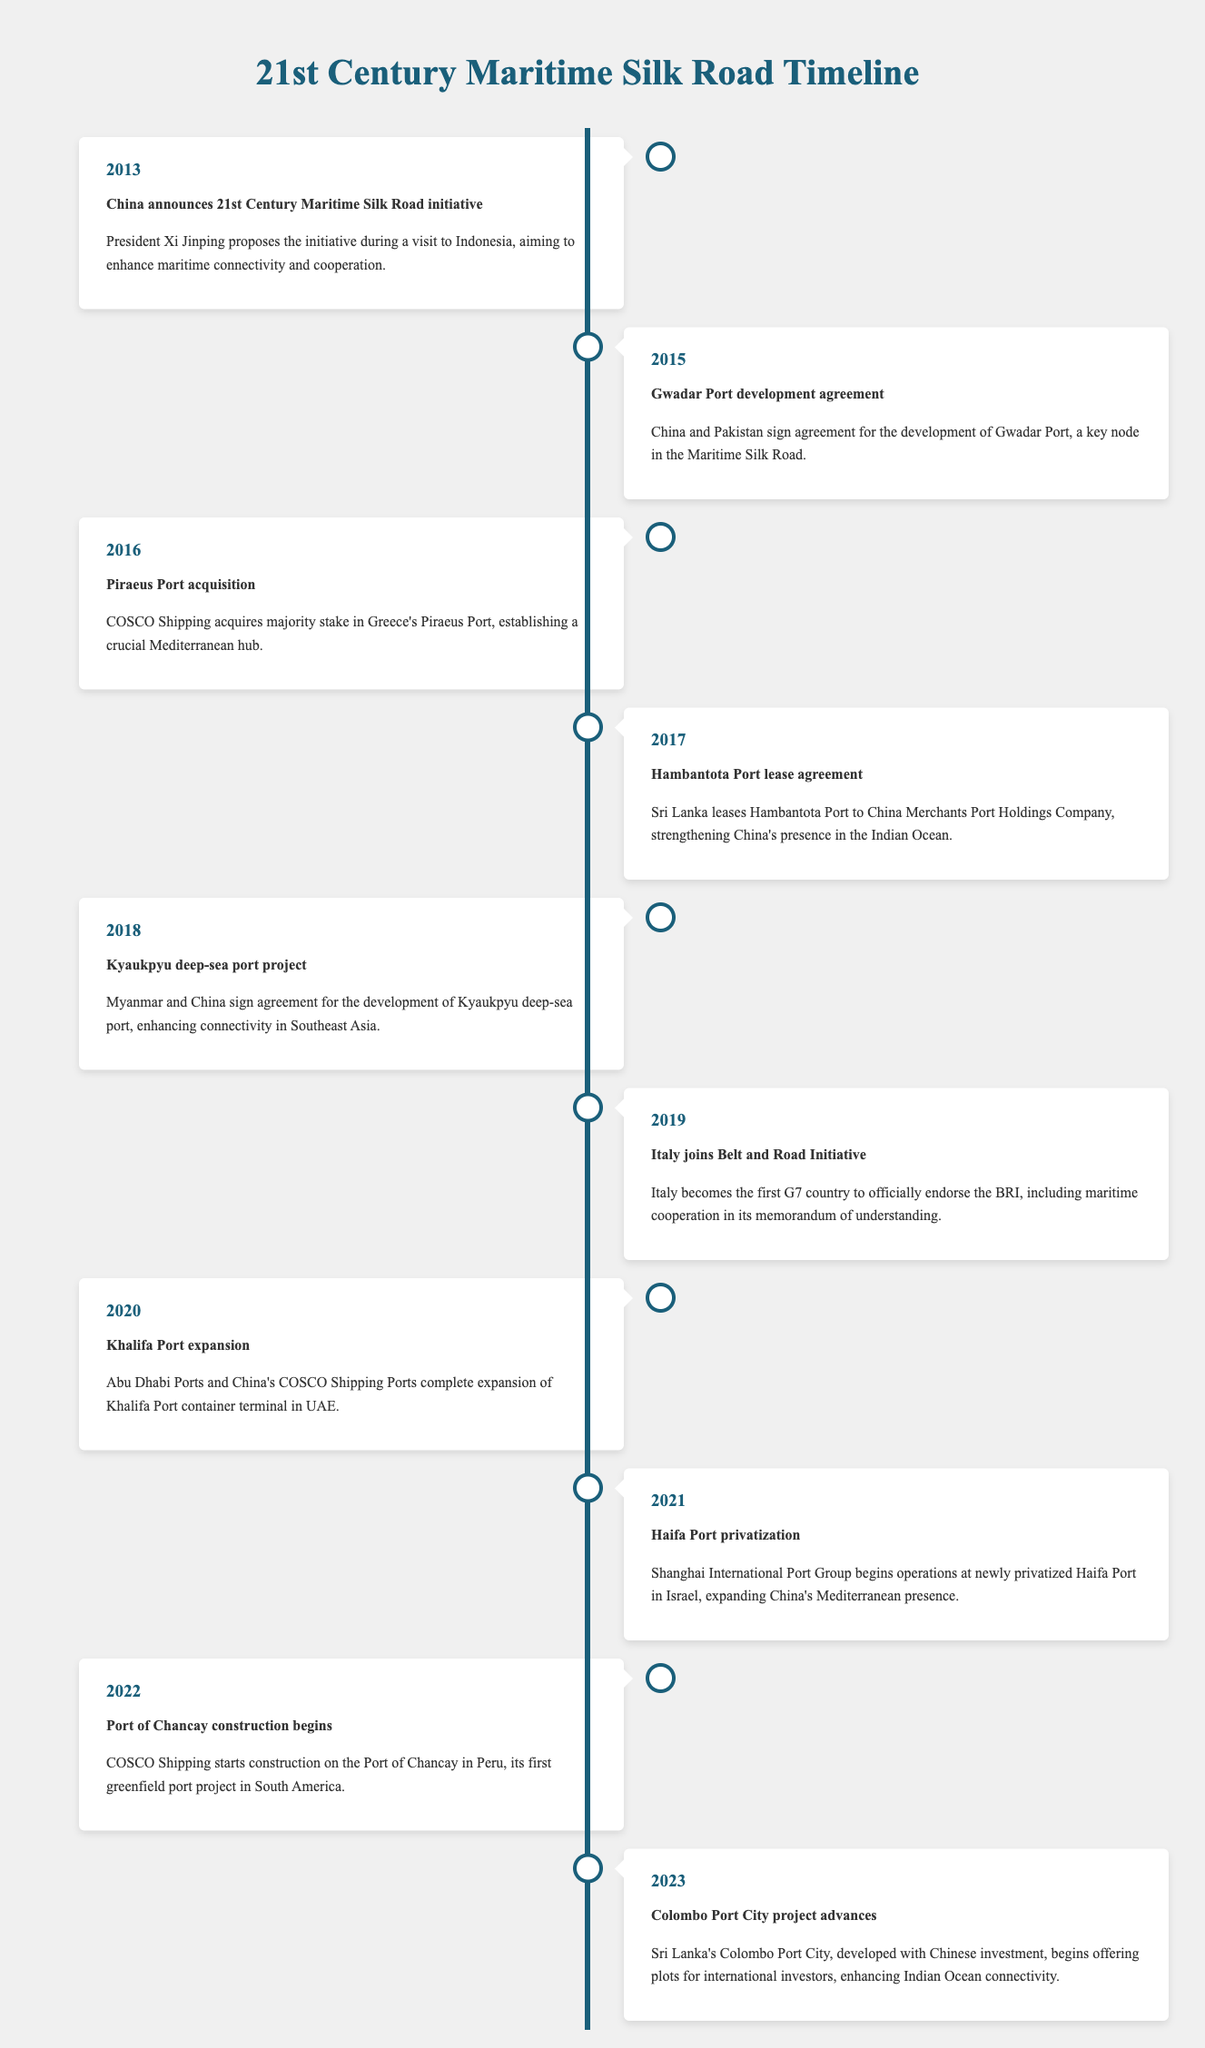What year was the 21st Century Maritime Silk Road initiative announced? The table shows that the initiative was announced in the year 2013, which is the first event listed.
Answer: 2013 Which country was involved in the Gwadar Port development agreement? According to the table, the Gwadar Port development agreement was signed between China and Pakistan in 2015.
Answer: Pakistan How many years passed between the announcement of the Maritime Silk Road and the acquisition of Piraeus Port? The initiative was announced in 2013, and the acquisition of Piraeus Port occurred in 2016. The difference is 2016 - 2013 = 3 years.
Answer: 3 years Was Italy the first G7 country to join the Belt and Road Initiative? Yes, the table specifically states that Italy became the first G7 country to endorse the initiative in 2019.
Answer: Yes What significant event regarding ports happened in 2021? In 2021, the table indicates that the Haifa Port was privatized and the Shanghai International Port Group began operations there, marking a significant event in that year.
Answer: Haifa Port privatization What is the trend of port development agreements from 2015 to 2023? Starting from 2015, several key port agreements occurred including Gwadar Port, Hambantota, and various expansions and projects. By 2023, the trend shows continued growth in international port development and cooperation.
Answer: Growth in port development Which country signed an agreement for the Kyaukpyu deep-sea port project? The table notes that Myanmar signed an agreement with China for the Kyaukpyu deep-sea port project in 2018.
Answer: Myanmar How many different ports are mentioned in the timeline from 2013 to 2023? The table includes mention of multiple ports: Gwadar, Piraeus, Hambantota, Kyaukpyu, Khalifa, Haifa, Chancay, and Colombo. Count shows a total of 8 different ports mentioned.
Answer: 8 ports Which event occurred first, the construction of the Port of Chancay or the expansion of Khalifa Port? The table shows that the expansion of Khalifa Port occurred in 2020, while construction for the Port of Chancay began in 2022. Therefore, the expansion of Khalifa Port occurred first.
Answer: Expansion of Khalifa Port 